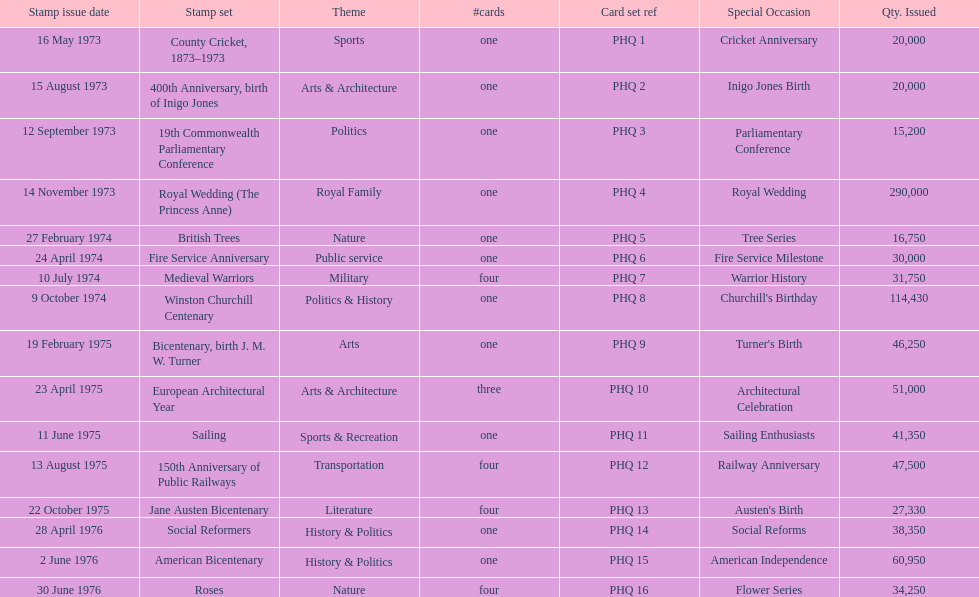How many stamp series were introduced in the year 1975? 5. 